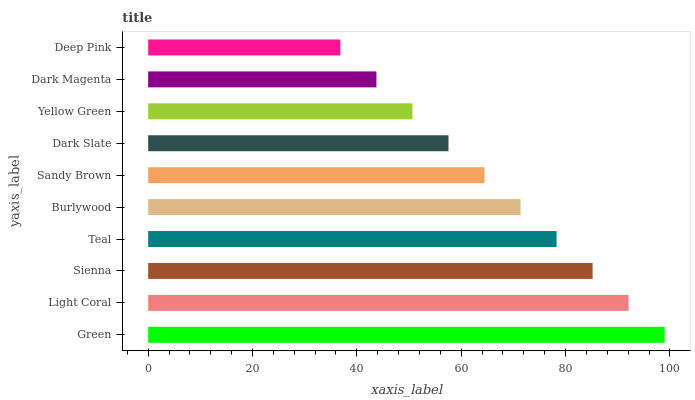Is Deep Pink the minimum?
Answer yes or no. Yes. Is Green the maximum?
Answer yes or no. Yes. Is Light Coral the minimum?
Answer yes or no. No. Is Light Coral the maximum?
Answer yes or no. No. Is Green greater than Light Coral?
Answer yes or no. Yes. Is Light Coral less than Green?
Answer yes or no. Yes. Is Light Coral greater than Green?
Answer yes or no. No. Is Green less than Light Coral?
Answer yes or no. No. Is Burlywood the high median?
Answer yes or no. Yes. Is Sandy Brown the low median?
Answer yes or no. Yes. Is Teal the high median?
Answer yes or no. No. Is Sienna the low median?
Answer yes or no. No. 